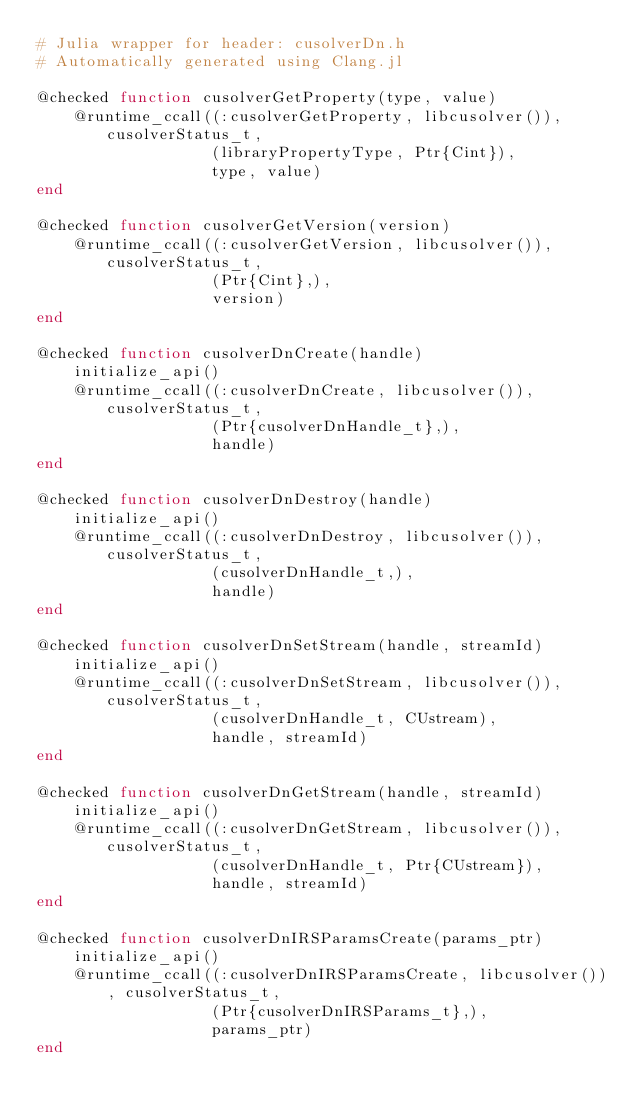Convert code to text. <code><loc_0><loc_0><loc_500><loc_500><_Julia_># Julia wrapper for header: cusolverDn.h
# Automatically generated using Clang.jl

@checked function cusolverGetProperty(type, value)
    @runtime_ccall((:cusolverGetProperty, libcusolver()), cusolverStatus_t,
                   (libraryPropertyType, Ptr{Cint}),
                   type, value)
end

@checked function cusolverGetVersion(version)
    @runtime_ccall((:cusolverGetVersion, libcusolver()), cusolverStatus_t,
                   (Ptr{Cint},),
                   version)
end

@checked function cusolverDnCreate(handle)
    initialize_api()
    @runtime_ccall((:cusolverDnCreate, libcusolver()), cusolverStatus_t,
                   (Ptr{cusolverDnHandle_t},),
                   handle)
end

@checked function cusolverDnDestroy(handle)
    initialize_api()
    @runtime_ccall((:cusolverDnDestroy, libcusolver()), cusolverStatus_t,
                   (cusolverDnHandle_t,),
                   handle)
end

@checked function cusolverDnSetStream(handle, streamId)
    initialize_api()
    @runtime_ccall((:cusolverDnSetStream, libcusolver()), cusolverStatus_t,
                   (cusolverDnHandle_t, CUstream),
                   handle, streamId)
end

@checked function cusolverDnGetStream(handle, streamId)
    initialize_api()
    @runtime_ccall((:cusolverDnGetStream, libcusolver()), cusolverStatus_t,
                   (cusolverDnHandle_t, Ptr{CUstream}),
                   handle, streamId)
end

@checked function cusolverDnIRSParamsCreate(params_ptr)
    initialize_api()
    @runtime_ccall((:cusolverDnIRSParamsCreate, libcusolver()), cusolverStatus_t,
                   (Ptr{cusolverDnIRSParams_t},),
                   params_ptr)
end
</code> 